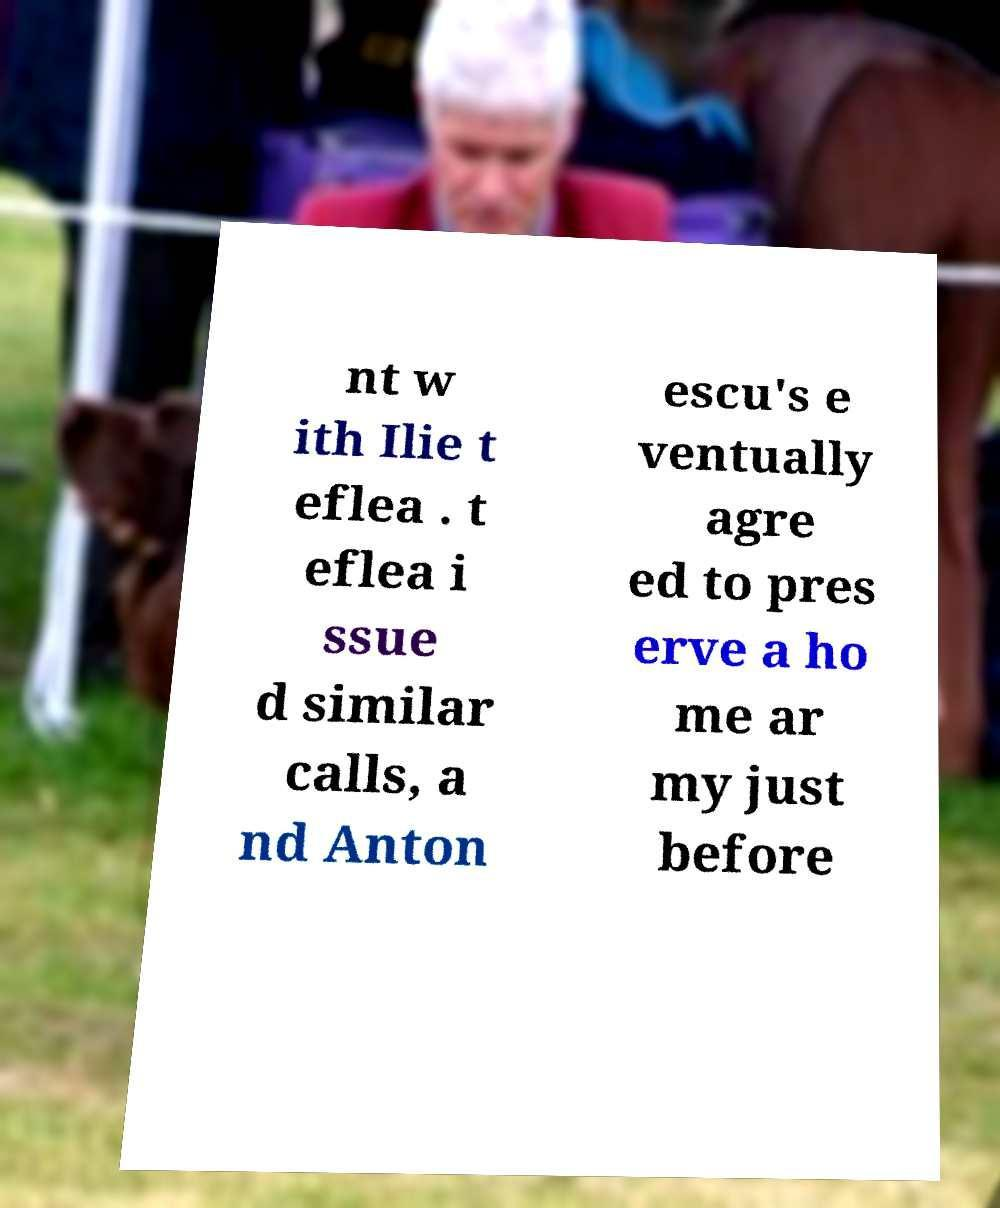Please identify and transcribe the text found in this image. nt w ith Ilie t eflea . t eflea i ssue d similar calls, a nd Anton escu's e ventually agre ed to pres erve a ho me ar my just before 